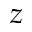Convert formula to latex. <formula><loc_0><loc_0><loc_500><loc_500>z</formula> 